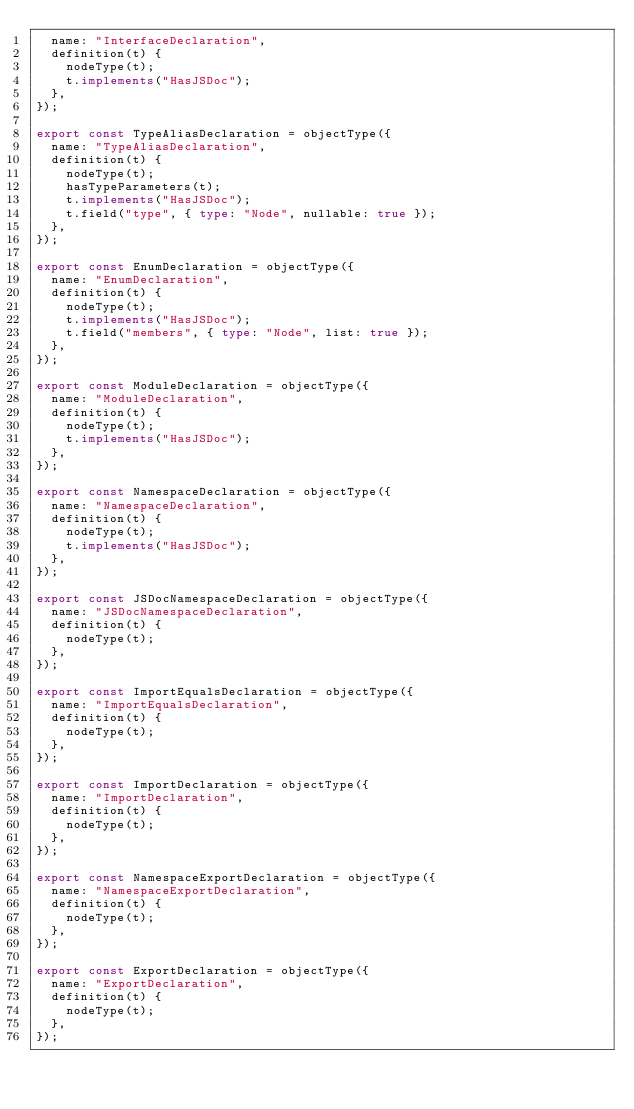Convert code to text. <code><loc_0><loc_0><loc_500><loc_500><_TypeScript_>  name: "InterfaceDeclaration",
  definition(t) {
    nodeType(t);
    t.implements("HasJSDoc");
  },
});

export const TypeAliasDeclaration = objectType({
  name: "TypeAliasDeclaration",
  definition(t) {
    nodeType(t);
    hasTypeParameters(t);
    t.implements("HasJSDoc");
    t.field("type", { type: "Node", nullable: true });
  },
});

export const EnumDeclaration = objectType({
  name: "EnumDeclaration",
  definition(t) {
    nodeType(t);
    t.implements("HasJSDoc");
    t.field("members", { type: "Node", list: true });
  },
});

export const ModuleDeclaration = objectType({
  name: "ModuleDeclaration",
  definition(t) {
    nodeType(t);
    t.implements("HasJSDoc");
  },
});

export const NamespaceDeclaration = objectType({
  name: "NamespaceDeclaration",
  definition(t) {
    nodeType(t);
    t.implements("HasJSDoc");
  },
});

export const JSDocNamespaceDeclaration = objectType({
  name: "JSDocNamespaceDeclaration",
  definition(t) {
    nodeType(t);
  },
});

export const ImportEqualsDeclaration = objectType({
  name: "ImportEqualsDeclaration",
  definition(t) {
    nodeType(t);
  },
});

export const ImportDeclaration = objectType({
  name: "ImportDeclaration",
  definition(t) {
    nodeType(t);
  },
});

export const NamespaceExportDeclaration = objectType({
  name: "NamespaceExportDeclaration",
  definition(t) {
    nodeType(t);
  },
});

export const ExportDeclaration = objectType({
  name: "ExportDeclaration",
  definition(t) {
    nodeType(t);
  },
});
</code> 